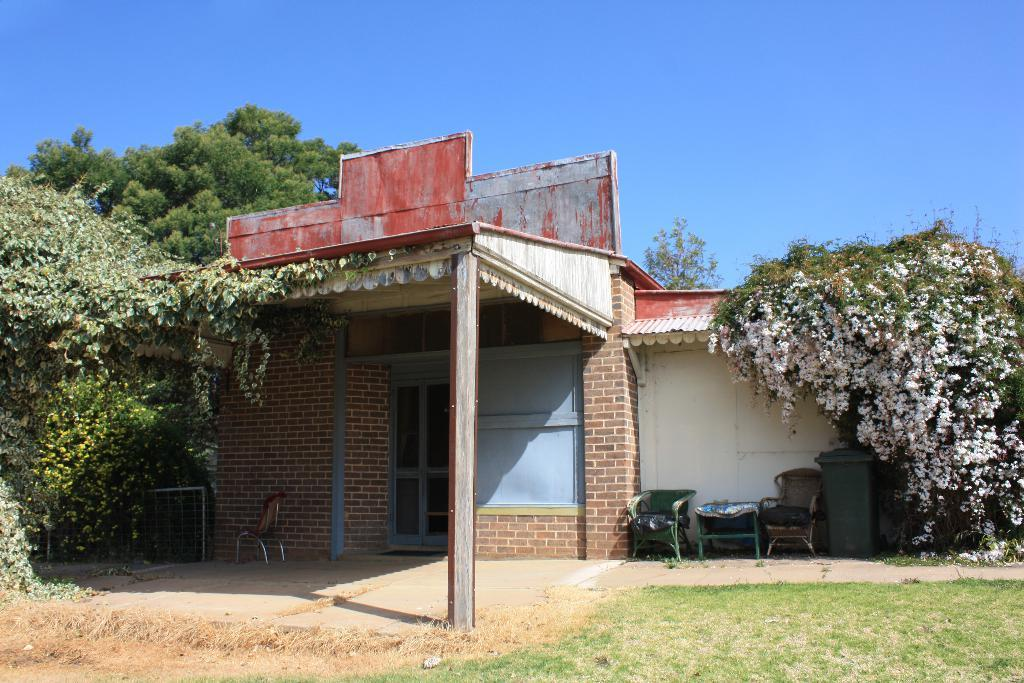What type of vegetation can be seen in the image? There is grass and trees in the image. What color is the container visible in the image? The container in the image is green. What type of furniture is present in the image? There are chairs in the image. What architectural feature can be seen in the image? There is a door in the image. What type of structure is visible in the image? There is a building in the image. What part of the natural environment is visible in the background of the image? The sky is visible in the background of the image. Can you hear the whistle of the train passing by in the image? There is no train or whistle present in the image. Is there a bridge visible in the image? There is no bridge present in the image. 